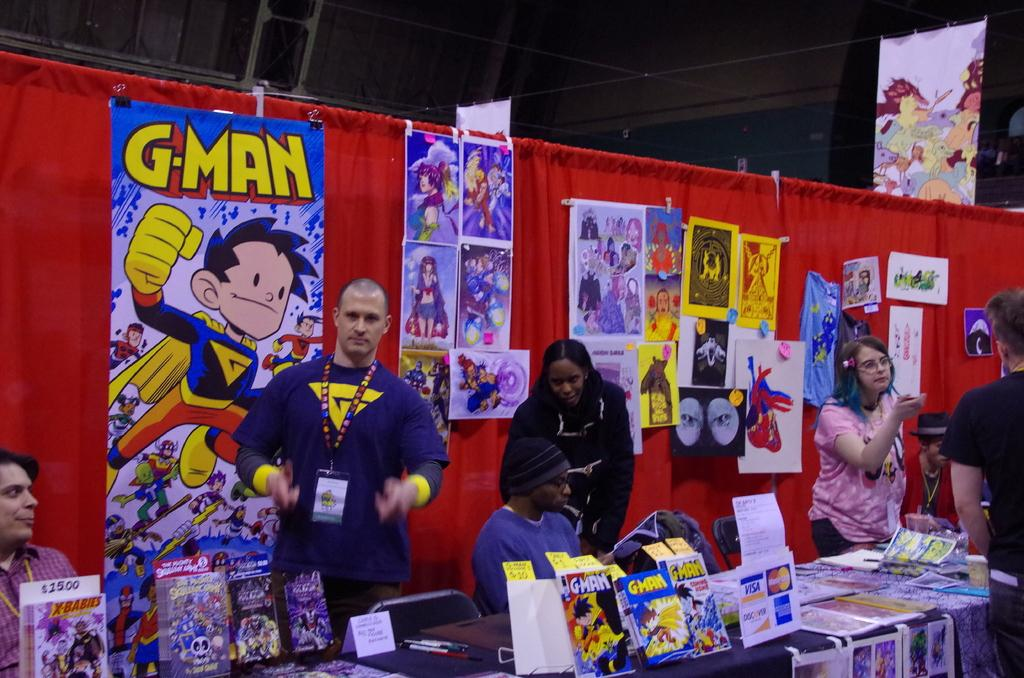<image>
Describe the image concisely. A display has a large colorful poster for Gman. 